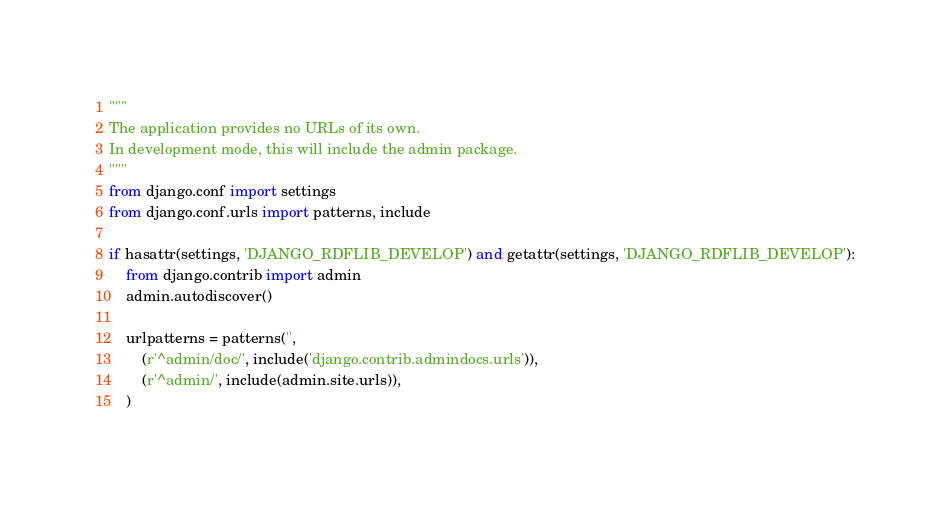<code> <loc_0><loc_0><loc_500><loc_500><_Python_>"""
The application provides no URLs of its own.
In development mode, this will include the admin package.
"""
from django.conf import settings
from django.conf.urls import patterns, include

if hasattr(settings, 'DJANGO_RDFLIB_DEVELOP') and getattr(settings, 'DJANGO_RDFLIB_DEVELOP'):
    from django.contrib import admin
    admin.autodiscover()

    urlpatterns = patterns('',
        (r'^admin/doc/', include('django.contrib.admindocs.urls')),
        (r'^admin/', include(admin.site.urls)),
    )
</code> 